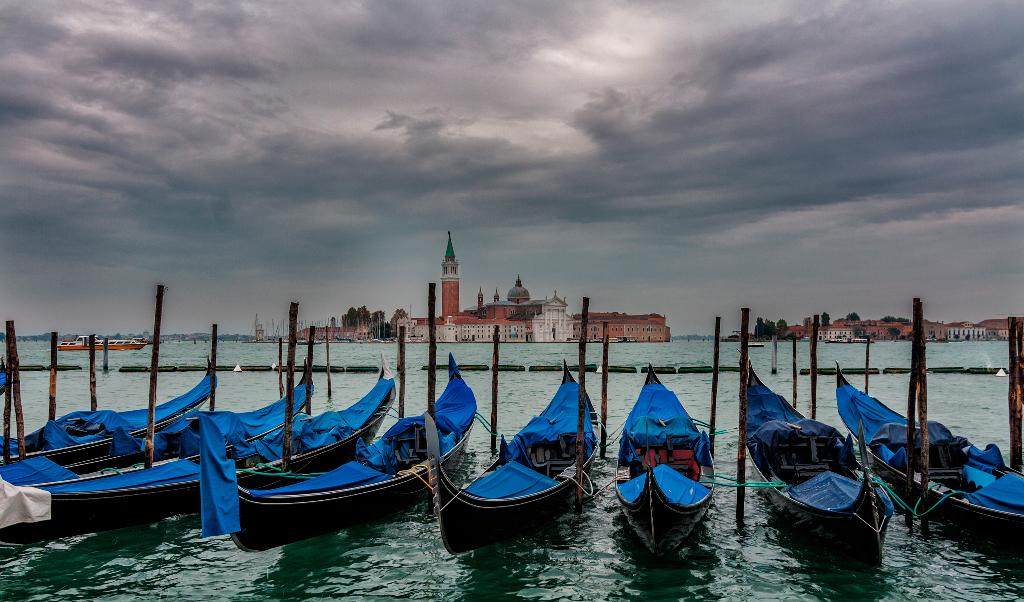What is in the water in the image? There are boats in the water. What can be seen in the background of the image? There are buildings, trees, and the sky visible in the background. Where are the dinosaurs located in the image? There are no dinosaurs present in the image. What is the motion of the boats in the image? The motion of the boats cannot be determined from the image alone, as it is a still picture. 